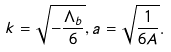Convert formula to latex. <formula><loc_0><loc_0><loc_500><loc_500>k = \sqrt { - \frac { \Lambda _ { b } } { 6 } } , a = \sqrt { \frac { 1 } { 6 A } } .</formula> 